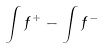Convert formula to latex. <formula><loc_0><loc_0><loc_500><loc_500>\int f ^ { + } - \int f ^ { - }</formula> 